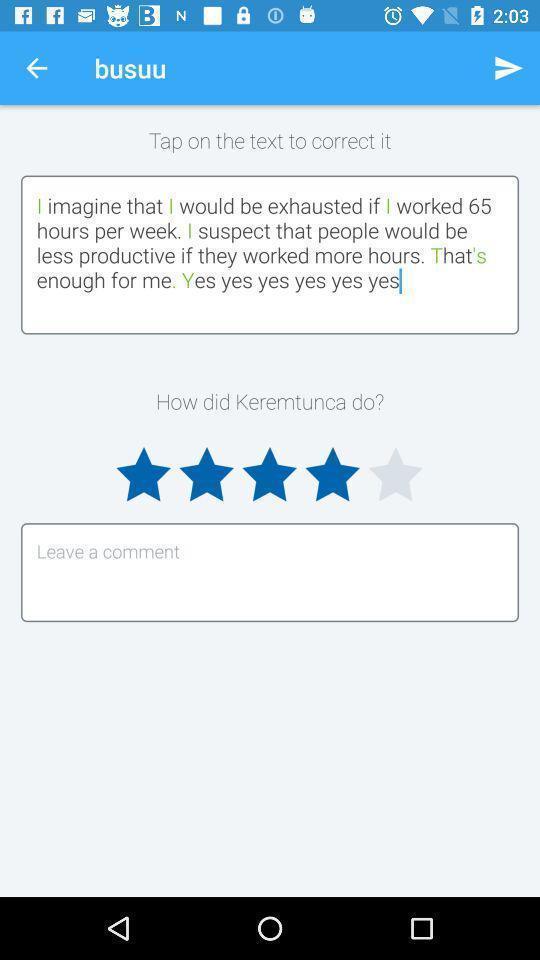Describe the key features of this screenshot. Text bar in a language learning app. 